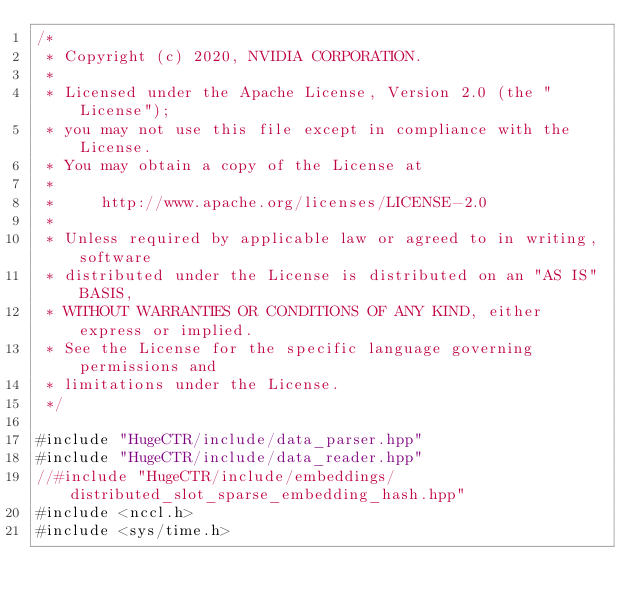<code> <loc_0><loc_0><loc_500><loc_500><_Cuda_>/*
 * Copyright (c) 2020, NVIDIA CORPORATION.
 *
 * Licensed under the Apache License, Version 2.0 (the "License");
 * you may not use this file except in compliance with the License.
 * You may obtain a copy of the License at
 *
 *     http://www.apache.org/licenses/LICENSE-2.0
 *
 * Unless required by applicable law or agreed to in writing, software
 * distributed under the License is distributed on an "AS IS" BASIS,
 * WITHOUT WARRANTIES OR CONDITIONS OF ANY KIND, either express or implied.
 * See the License for the specific language governing permissions and
 * limitations under the License.
 */

#include "HugeCTR/include/data_parser.hpp"
#include "HugeCTR/include/data_reader.hpp"
//#include "HugeCTR/include/embeddings/distributed_slot_sparse_embedding_hash.hpp"
#include <nccl.h>
#include <sys/time.h></code> 